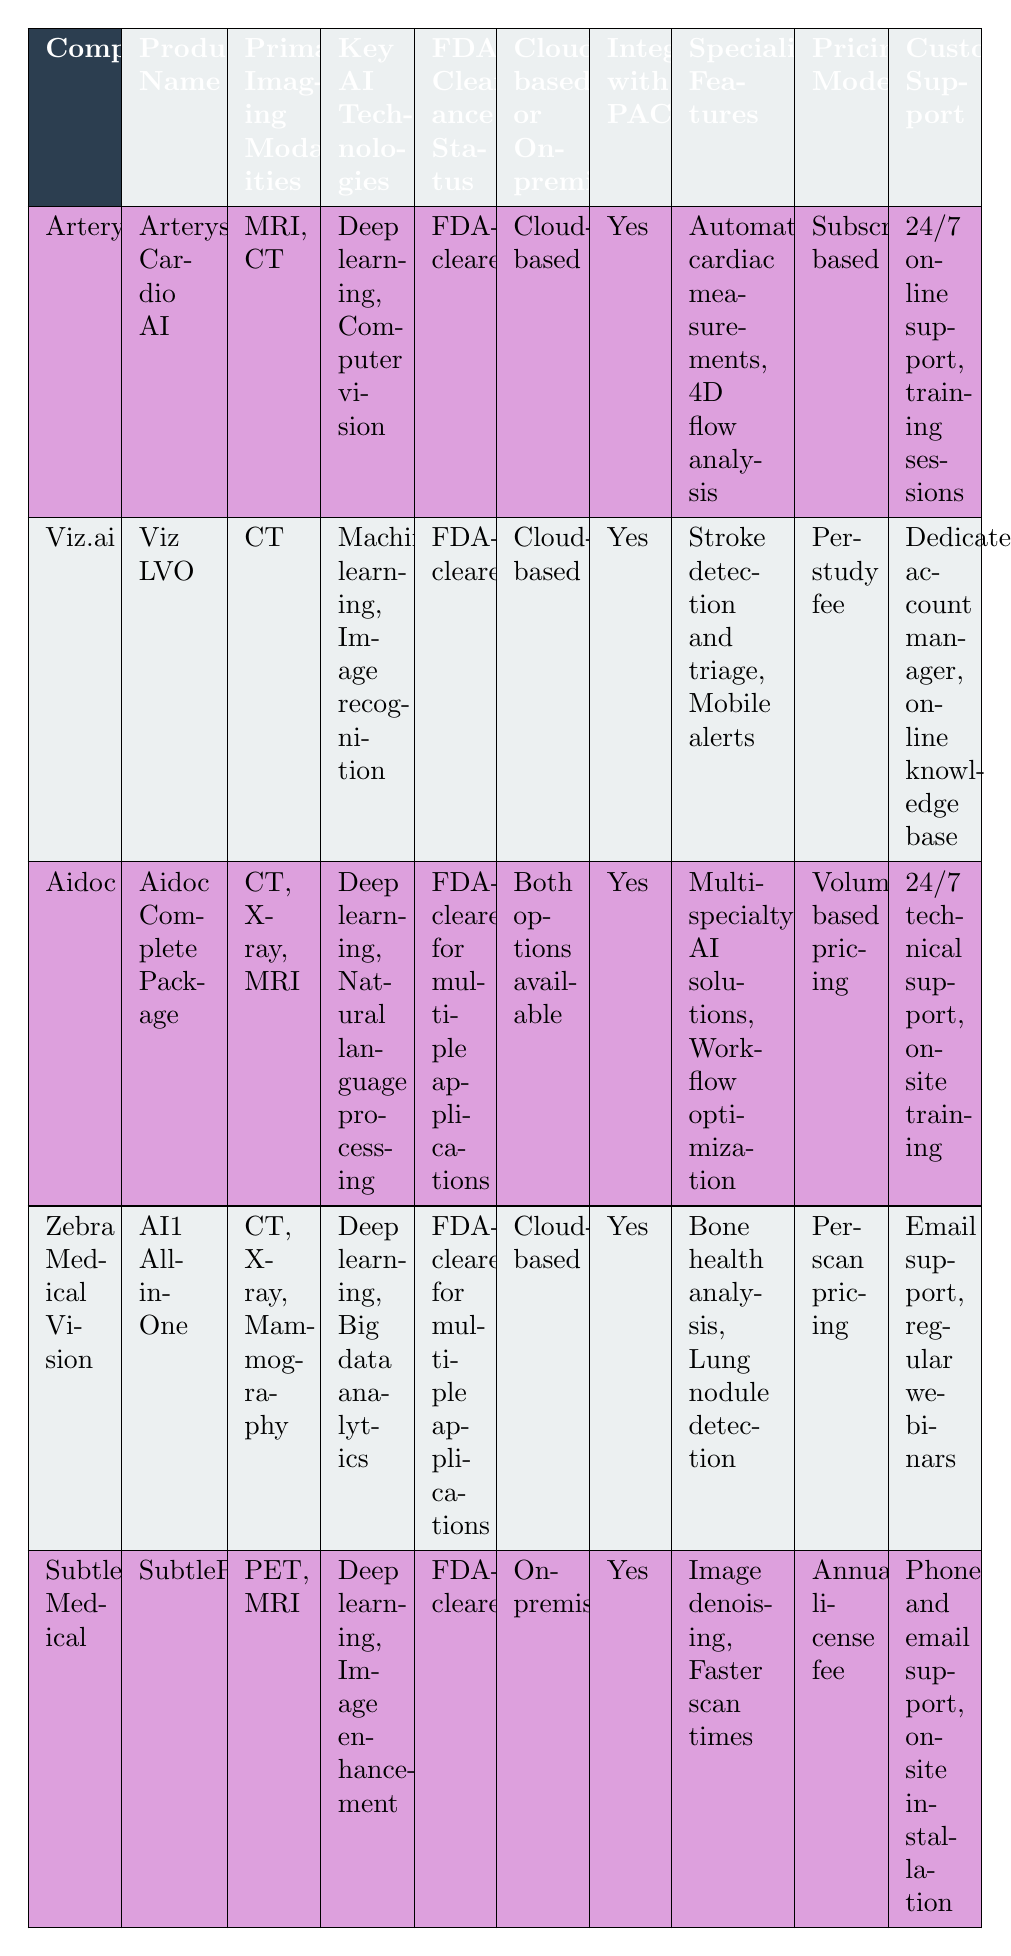What are the primary imaging modalities supported by Arterys Cardio AI? The primary imaging modalities that Arterys Cardio AI supports are listed under the "Primary Imaging Modalities" column adjacent to the company name. For Arterys, these are MRI and CT.
Answer: MRI, CT Is Aidoc’s software available in cloud-based format? To determine this, we look at the "Cloud-based or On-premise" column for Aidoc. It states "Both options available," which indicates that it can be accessed in the cloud.
Answer: Yes How many companies have FDA-cleared software for multiple applications? We can find the relevant companies by looking at the "FDA Clearance Status" column and identifying those that mention being FDA-cleared for multiple applications. According to the table, Aidoc and Zebra Medical Vision both have this status, making a total of 2 companies.
Answer: 2 Which company offers 24/7 technical support? The column "Customer Support" needs to be checked for each company to see who provides this service. Aidoc specifically mentions "24/7 technical support," while other companies provide different forms of support.
Answer: Aidoc What is the unique specialized feature of Zebra Medical Vision compared to other companies? To find this, review the "Specialized Features" column. Zebra Medical Vision mentions "Bone health analysis, Lung nodule detection," which distinguishes it from the others as no other company lists these features.
Answer: Bone health analysis, Lung nodule detection How does the pricing model of Viz.ai compare to that of Aidoc? We look at the "Pricing Model" for both companies. Viz.ai uses a "Per-study fee" model, whereas Aidoc adopts a "Volume-based pricing" model. This indicates they utilize different approaches based on how they charge customers.
Answer: Different approaches Which company has on-premise software and what is its primary imaging modality? In the "Cloud-based or On-premise" column, Subtle Medical is identified as having on-premise software. The "Primary Imaging Modalities" column shows that its primary modality is PET and MRI.
Answer: Subtle Medical, PET, MRI What is the common integration feature across all listed companies? By reviewing the "Integration with PACS/RIS" column for each company, we see that every company mentions "Yes," indicating that they all offer integration capabilities.
Answer: Yes Calculate the total number of imaging modalities supported by the products from the companies listed in the table. We count the number of modalities under "Primary Imaging Modalities" for each company: Arterys has 2 (MRI, CT), Viz.ai has 1 (CT), Aidoc has 3 (CT, X-ray, MRI), Zebra Medical Vision has 3 (CT, X-ray, Mammography), and Subtle Medical has 2 (PET, MRI). Adding these together gives 2 + 1 + 3 + 3 + 2 = 11.
Answer: 11 